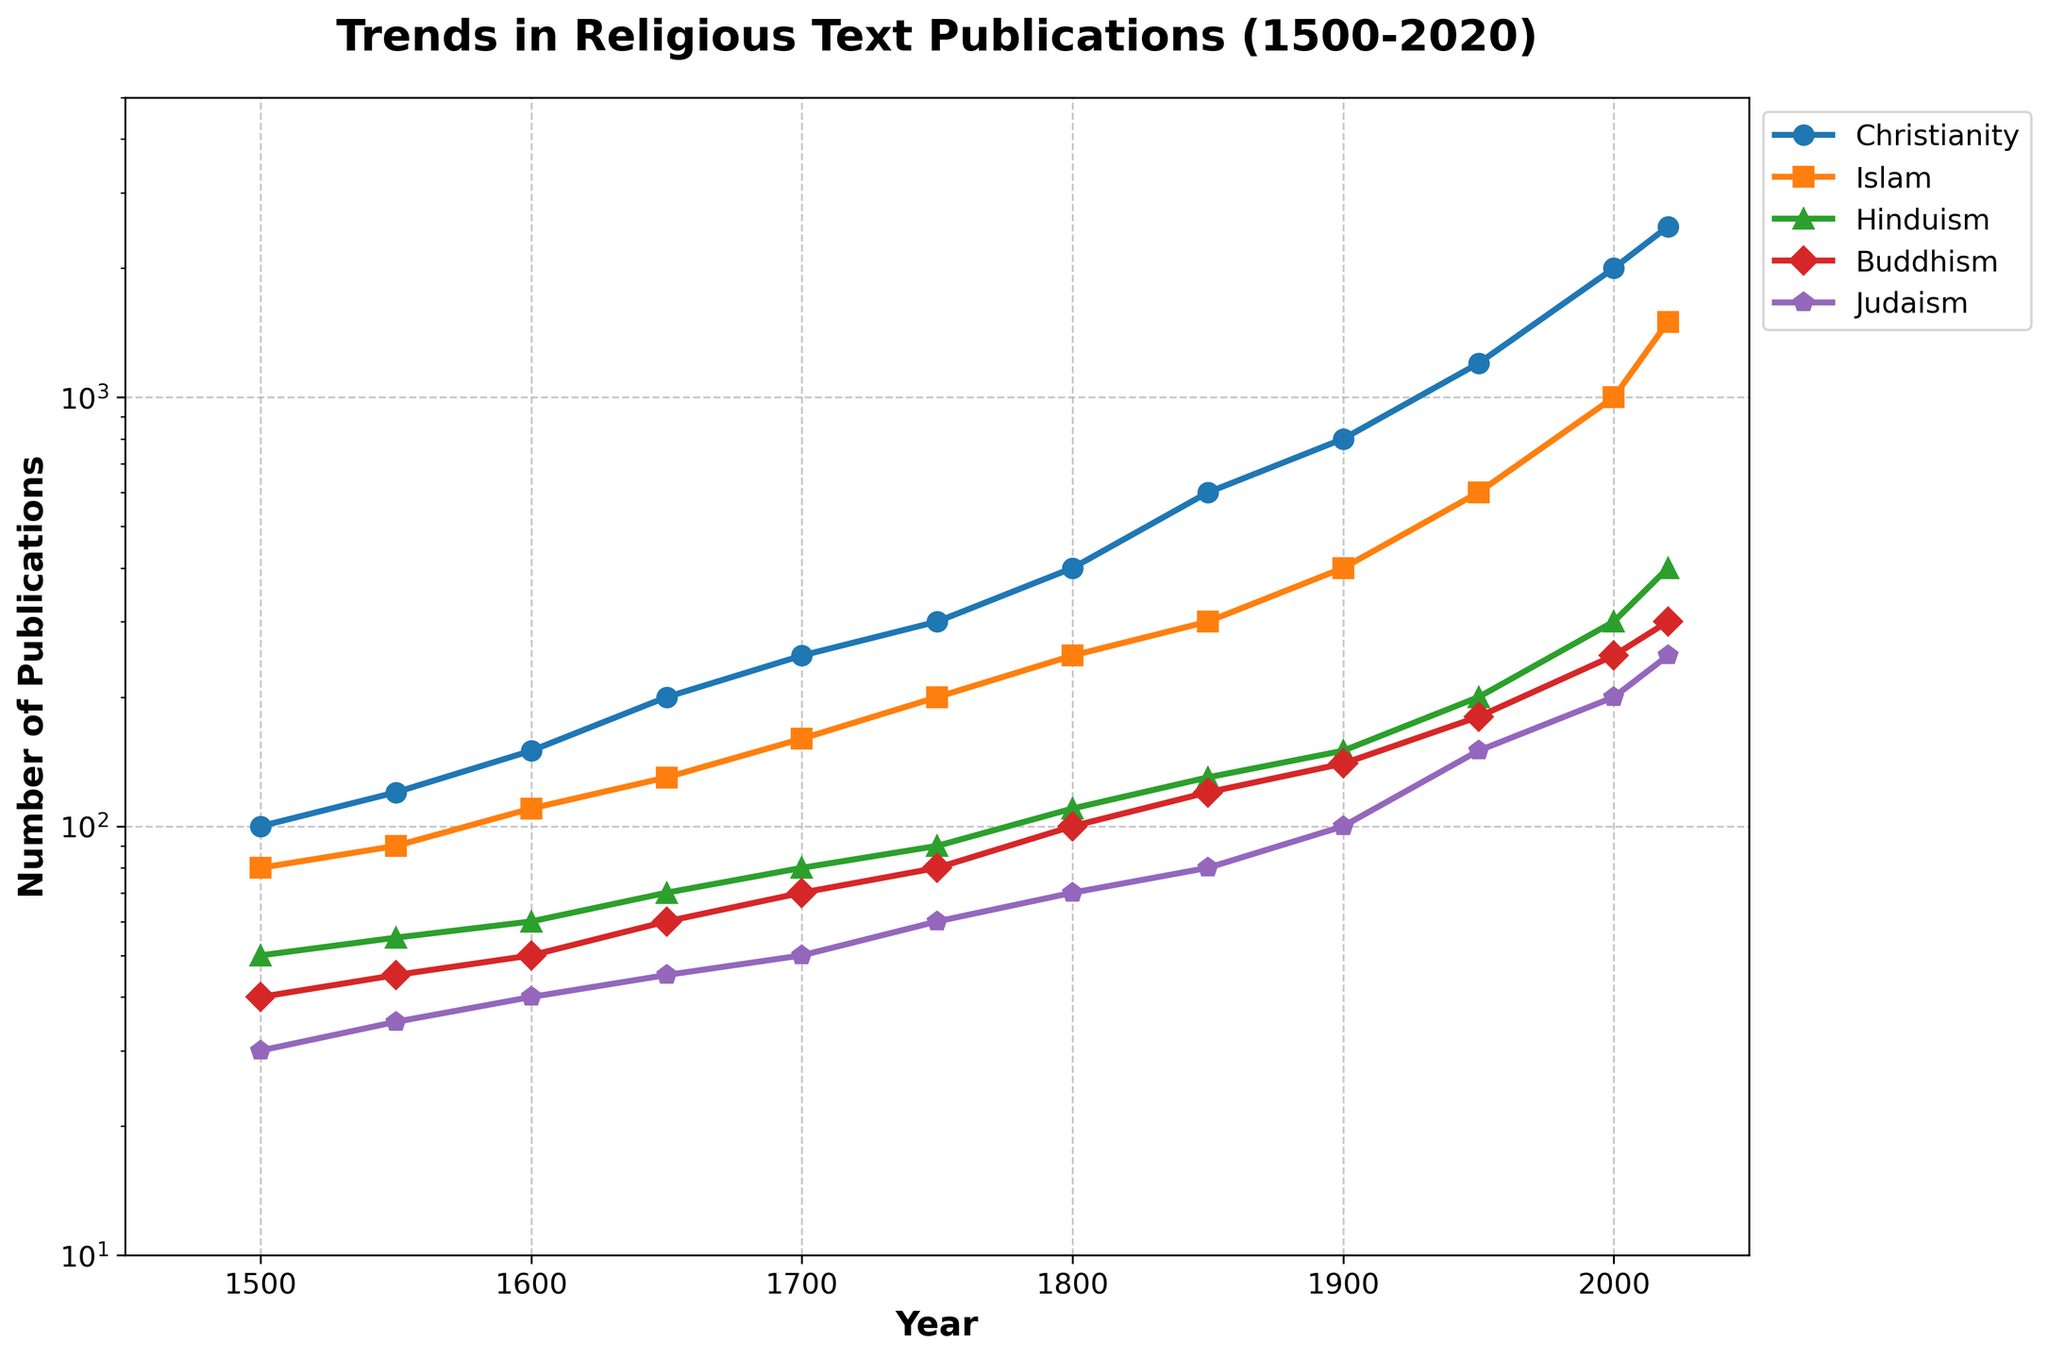What decade saw the steepest increase in publications for Christianity? To find the steepest increase for Christianity, observe the segments of the Christianity trend line. The largest jump is between 1900 and 1950, where the number of publications increased from 800 to 1200.
Answer: 1900-1950 Which religion had the least number of publications in 1950? Look at the data points for the year 1950 and compare the heights of the different markers. Judaism has the lowest value at around 150 publications.
Answer: Judaism What is the difference in the number of Christian and Islamic publications in the year 2000? Identify the values for Christianity (2000) and Islam (1000) in the year 2000. Subtract the Islamic publications from the Christian publications: 2000 - 1000 = 1000.
Answer: 1000 Between 1600 and 1800, which religion experienced the highest multiplication factor in the number of publications? Calculate the ratio of publications between 1600 and 1800 for each religion. For Christianity: 400/150 ≈ 2.67; Islam: 250/110 ≈ 2.27; Hinduism: 110/60 ≈ 1.83; Buddhism: 100/50 = 2; Judaism: 70/40 = 1.75. Christianity has the highest multiplication factor.
Answer: Christianity Which religion had the closest number of publications in 2020 compared to the average number of Hindu publications from 1500 to 2020? First, calculate the average number of Hindu publications: (50 + 55 + 60 + 70 + 80 + 90 + 110 + 130 + 150 + 200 + 300 + 400) / 12 ≈ 141.7. Then, compare the 2020 publications for each religion. The closest value is the Judaic publications of 250.
Answer: Judaism In which year did Buddhism surpass the 100 publication mark? Note the value of Buddhism publications for each year and identify the first year when the number exceeds 100. In this case, it is in 1850 (value of 120).
Answer: 1850 By how much did the number of Islamic publications grow between 1550 and 1800? Identify the values of Islamic publications for 1550 (90) and 1800 (250). Calculate the difference: 250 - 90 = 160.
Answer: 160 Which religion shows the lowest variability in publication trends over the 500-year period? Observe the gradient and smoothness of the lines over the time period. Both Judaism and Hinduism show relatively smooth and steady increases compared to others. However, Judaism has the fewest drastic changes.
Answer: Judaism 